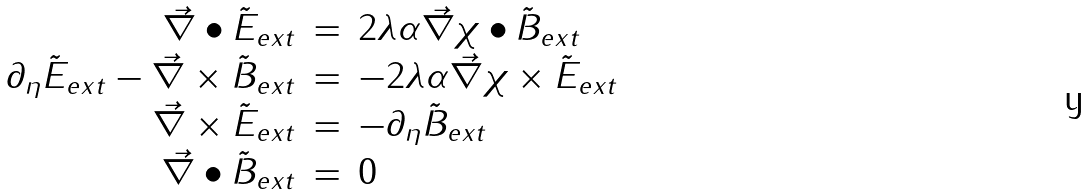<formula> <loc_0><loc_0><loc_500><loc_500>\begin{array} { r r l } \vec { \nabla } \bullet \tilde { E } _ { e x t } & = & 2 \lambda \alpha \vec { \nabla } \chi \bullet \tilde { B } _ { e x t } \\ \partial _ { \eta } \tilde { E } _ { e x t } - \vec { \nabla } \times \tilde { B } _ { e x t } & = & - 2 \lambda \alpha \vec { \nabla } \chi \times \tilde { E } _ { e x t } \\ \vec { \nabla } \times \tilde { E } _ { e x t } & = & - \partial _ { \eta } \tilde { B } _ { e x t } \\ \vec { \nabla } \bullet \tilde { B } _ { e x t } & = & 0 \end{array}</formula> 